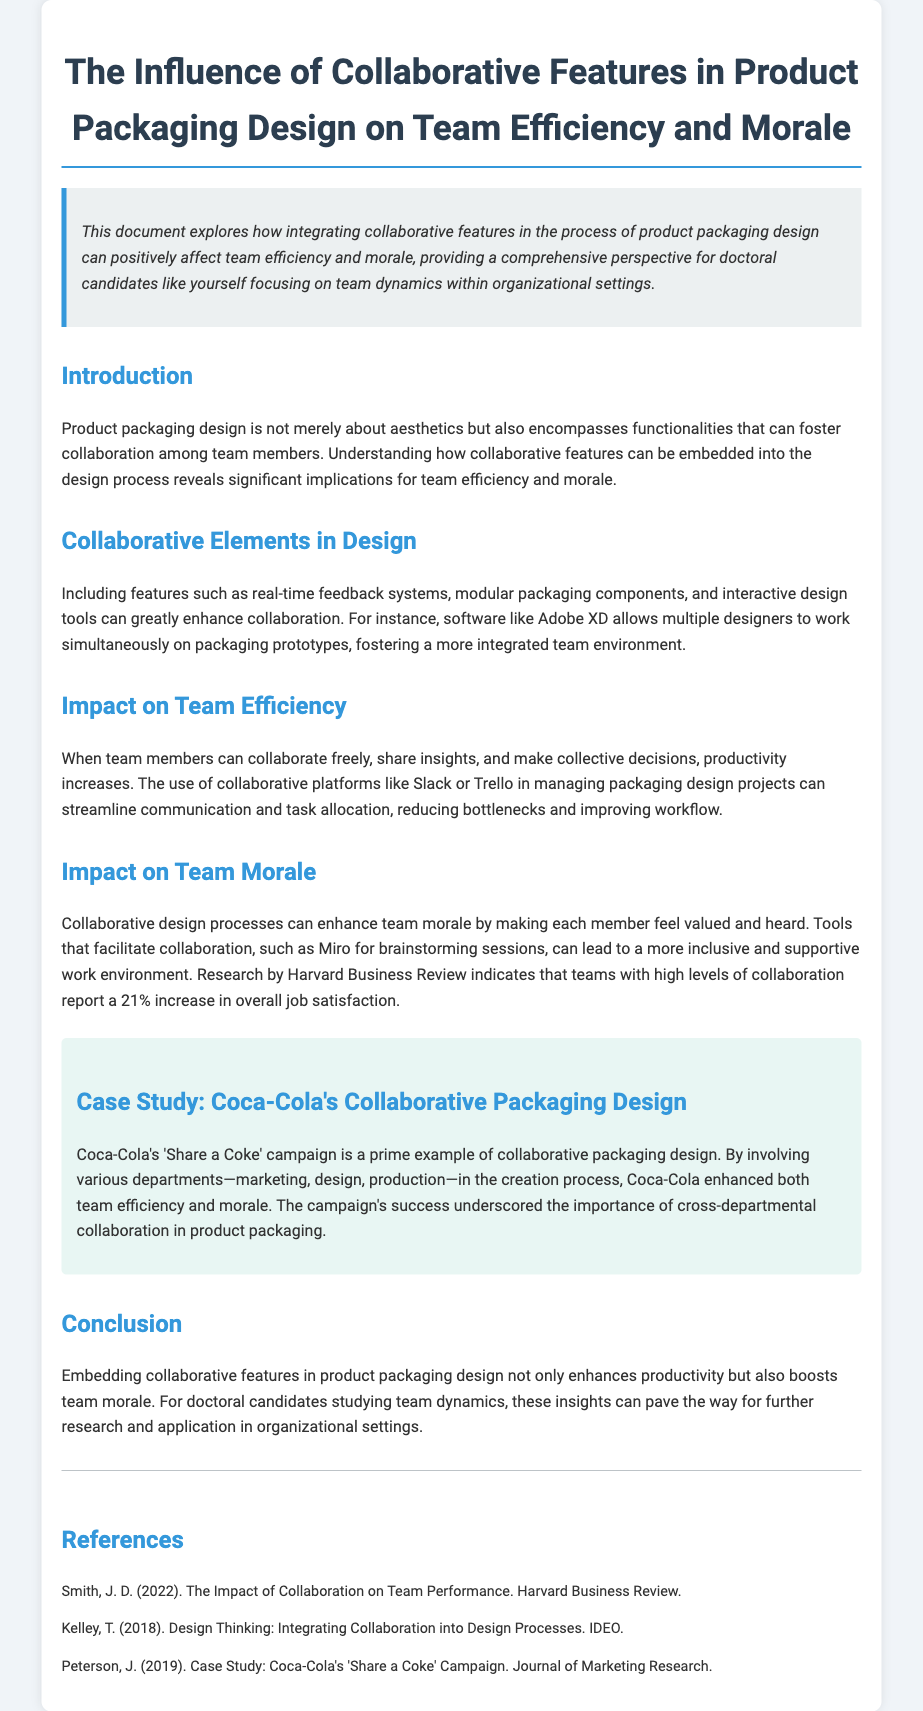What is the title of the document? The title of the document is presented prominently at the top of the document.
Answer: The Influence of Collaborative Features in Product Packaging Design on Team Efficiency and Morale What tool is mentioned for collaborative design? The document discusses specific software used for collaborative design processes.
Answer: Adobe XD What percentage increase in job satisfaction is reported with high collaboration? The document cites a specific statistic related to job satisfaction in the context of collaboration.
Answer: 21% What is the main case study highlighted in the document? The case study section offers a specific example of a well-known brand and its approach to packaging design.
Answer: Coca-Cola's 'Share a Coke' campaign What is one collaborative feature mentioned that enhances team efficiency? The document outlines various features that promote team efficiency.
Answer: Real-time feedback systems What do collaborative processes enhance in team members according to the document? The document discusses the emotional and motivational impacts of collaborative processes on team members.
Answer: Morale How many references are listed in the document? The references section provides a count of sources cited throughout the document.
Answer: Three What type of environment do tools like Miro create? The document describes the effects of certain collaborative tools on the work environment.
Answer: Inclusive and supportive 